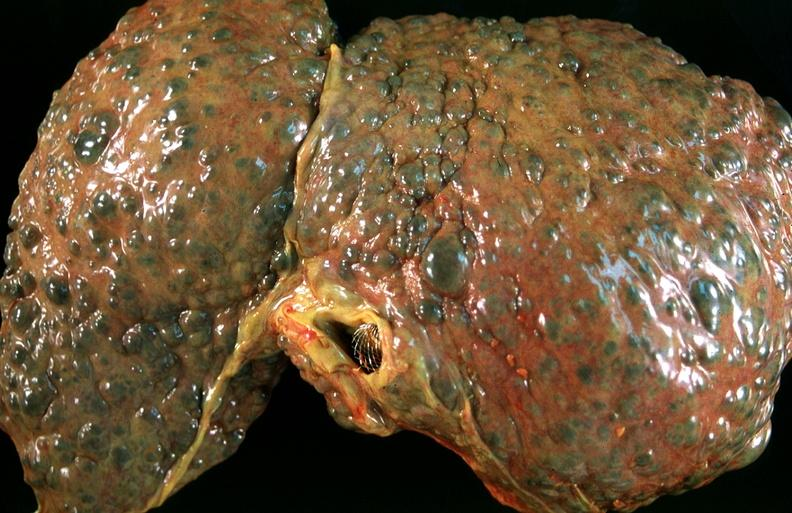does rocky mountain show liver, macronodular cirrhosis, hcv?
Answer the question using a single word or phrase. No 